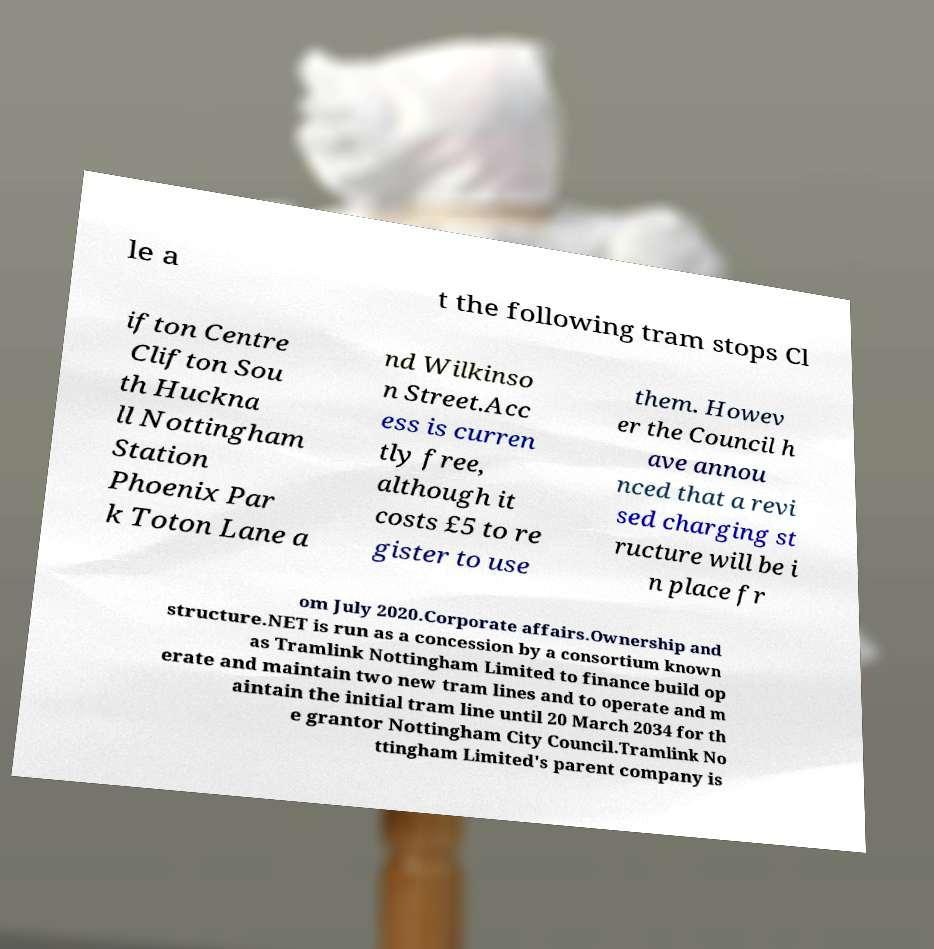Could you extract and type out the text from this image? le a t the following tram stops Cl ifton Centre Clifton Sou th Huckna ll Nottingham Station Phoenix Par k Toton Lane a nd Wilkinso n Street.Acc ess is curren tly free, although it costs £5 to re gister to use them. Howev er the Council h ave annou nced that a revi sed charging st ructure will be i n place fr om July 2020.Corporate affairs.Ownership and structure.NET is run as a concession by a consortium known as Tramlink Nottingham Limited to finance build op erate and maintain two new tram lines and to operate and m aintain the initial tram line until 20 March 2034 for th e grantor Nottingham City Council.Tramlink No ttingham Limited's parent company is 